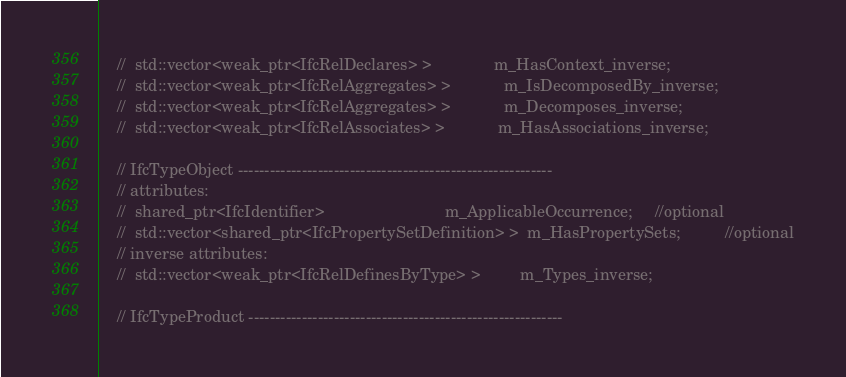Convert code to text. <code><loc_0><loc_0><loc_500><loc_500><_C_>	//  std::vector<weak_ptr<IfcRelDeclares> >				m_HasContext_inverse;
	//  std::vector<weak_ptr<IfcRelAggregates> >			m_IsDecomposedBy_inverse;
	//  std::vector<weak_ptr<IfcRelAggregates> >			m_Decomposes_inverse;
	//  std::vector<weak_ptr<IfcRelAssociates> >			m_HasAssociations_inverse;

	// IfcTypeObject -----------------------------------------------------------
	// attributes:
	//  shared_ptr<IfcIdentifier>							m_ApplicableOccurrence;		//optional
	//  std::vector<shared_ptr<IfcPropertySetDefinition> >	m_HasPropertySets;			//optional
	// inverse attributes:
	//  std::vector<weak_ptr<IfcRelDefinesByType> >			m_Types_inverse;

	// IfcTypeProduct -----------------------------------------------------------</code> 